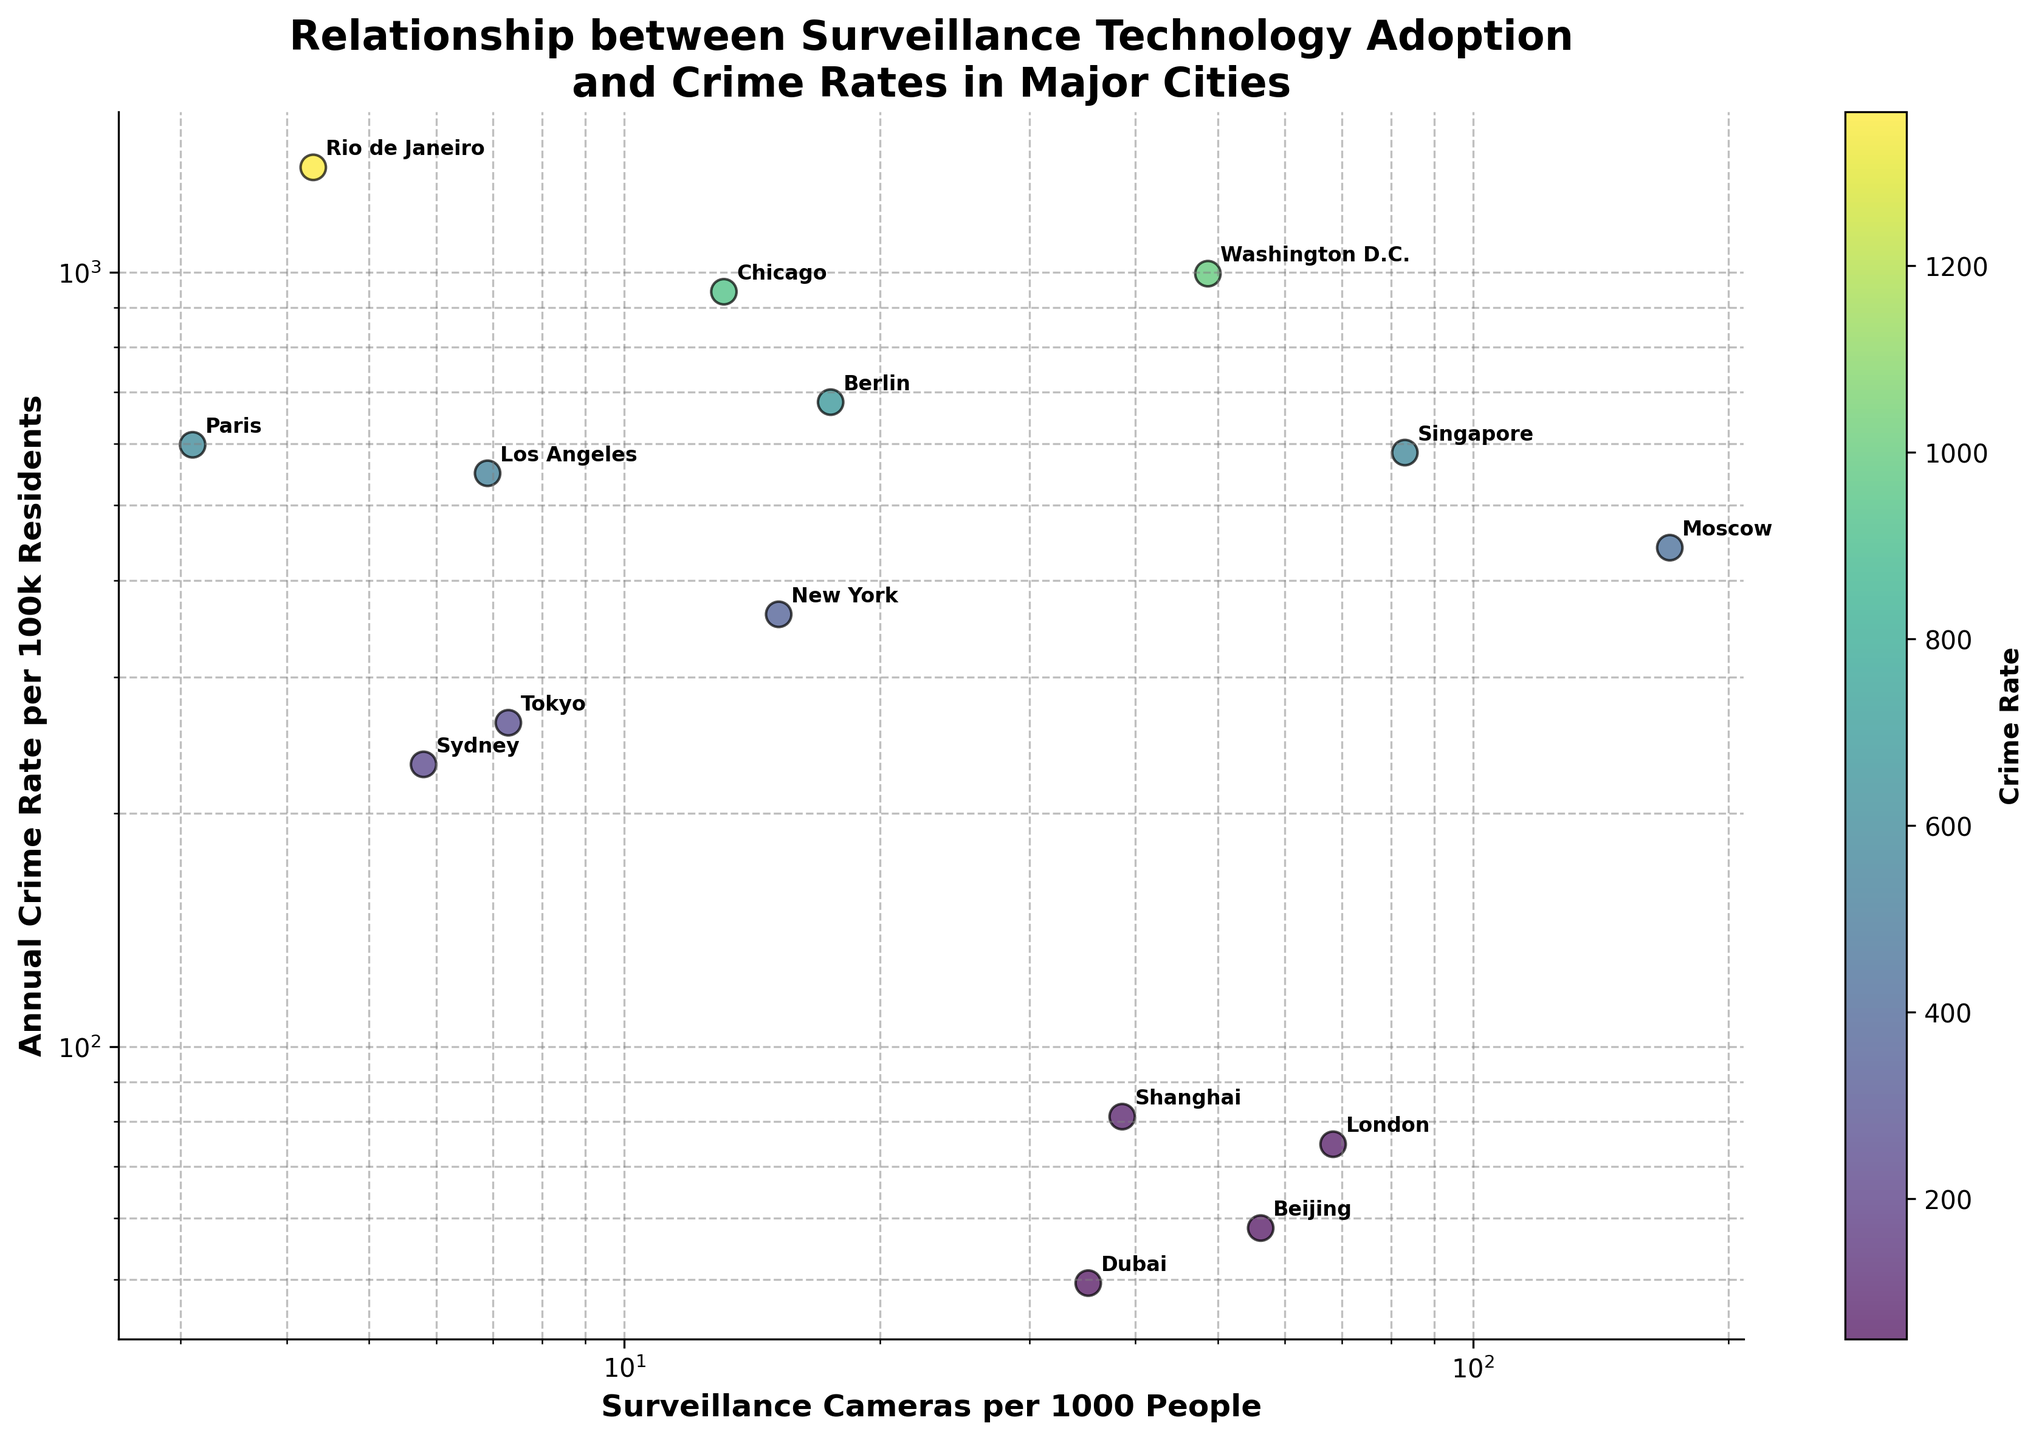What's the title of the figure? The title of the figure is usually displayed at the top, summarizing the main topic or objective of the plot. In this case, the title reads "Relationship between Surveillance Technology Adoption and Crime Rates in Major Cities".
Answer: Relationship between Surveillance Technology Adoption and Crime Rates in Major Cities How many cities are represented in the scatter plot? Each city corresponds to a data point on the scatter plot. By counting the annotated city names, we can determine there are 15 cities in total.
Answer: 15 Which city has the highest number of surveillance cameras per 1000 people? By looking at the x-axis, which is labeled 'Surveillance Cameras per 1000 People', and identifying the data point furthest to the right, we can see that Moscow has the highest number of surveillance cameras per 1000 people, with 170.5 cameras.
Answer: Moscow Which city has the highest annual crime rate per 100k residents? By looking at the y-axis, which is labeled 'Annual Crime Rate per 100k Residents', and identifying the data point highest on the axis, it is apparent that Rio de Janeiro has the highest annual crime rate per 100k residents, with 1365.2.
Answer: Rio de Janeiro Describe the relationship, if any, between the number of surveillance cameras and the crime rate in these cities. The scatter plot shows no clear, simple trend; some cities like Moscow and Singapore have high camera counts but also high crime rates, while cities like Dubai have moderate camera counts and low crime rates. This indicates that the relationship between surveillance cameras and crime rate might not be straightforward.
Answer: No clear trend Which city with fewer than 10 surveillance cameras per 1000 people has the lowest crime rate? By observing cities with data points to the left of the x=10 line and then looking at their corresponding y-values, it is clear that Sydney has the lowest crime rate of 231.4 among those with fewer than 10 surveillance cameras per 1000 people.
Answer: Sydney Which city has a relatively high number of surveillance cameras but a low crime rate? The data point for Dubai stands out as it is positioned with a relatively high number of surveillance cameras (35.2) and a low crime rate (49.5), shown by its location toward the lower middle of the plot.
Answer: Dubai Compare the crime rates of Beijing and Shanghai. Which city has a higher crime rate and by how much? By locating Beijing and Shanghai on the plot, we can see Beijing has a crime rate of 58.3, while Shanghai has a crime rate of 81.2. The difference in crime rates can be calculated like this: 81.2 - 58.3 = 22.9. Therefore, Shanghai has a higher crime rate by 22.9 per 100k residents.
Answer: 22.9 What is the range of surveillance cameras per 1000 people across all cities? To find the range, we identify the minimum and maximum values on the x-axis. Paris has the fewest surveillance cameras (3.1), and Moscow has the most (170.5). Therefore, the range is calculated as 170.5 - 3.1 = 167.4 cameras per 1000 people.
Answer: 167.4 Is there a city with a significantly high crime rate but a very low number of surveillance cameras? By identifying the extreme outliers in the plot, Rio de Janeiro stands out with a very high crime rate of 1365.2 per 100k residents and a low number of surveillance cameras, only 4.3 per 1000 people.
Answer: Rio de Janeiro 